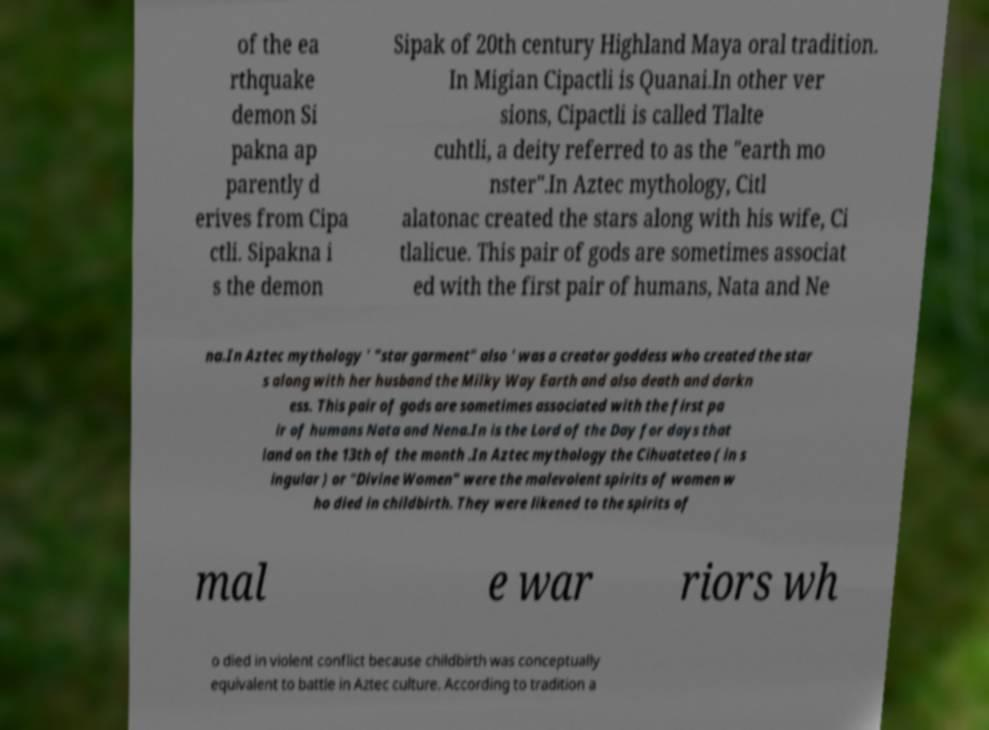There's text embedded in this image that I need extracted. Can you transcribe it verbatim? of the ea rthquake demon Si pakna ap parently d erives from Cipa ctli. Sipakna i s the demon Sipak of 20th century Highland Maya oral tradition. In Migian Cipactli is Quanai.In other ver sions, Cipactli is called Tlalte cuhtli, a deity referred to as the "earth mo nster".In Aztec mythology, Citl alatonac created the stars along with his wife, Ci tlalicue. This pair of gods are sometimes associat ed with the first pair of humans, Nata and Ne na.In Aztec mythology ' "star garment" also ' was a creator goddess who created the star s along with her husband the Milky Way Earth and also death and darkn ess. This pair of gods are sometimes associated with the first pa ir of humans Nata and Nena.In is the Lord of the Day for days that land on the 13th of the month .In Aztec mythology the Cihuateteo ( in s ingular ) or "Divine Women" were the malevolent spirits of women w ho died in childbirth. They were likened to the spirits of mal e war riors wh o died in violent conflict because childbirth was conceptually equivalent to battle in Aztec culture. According to tradition a 